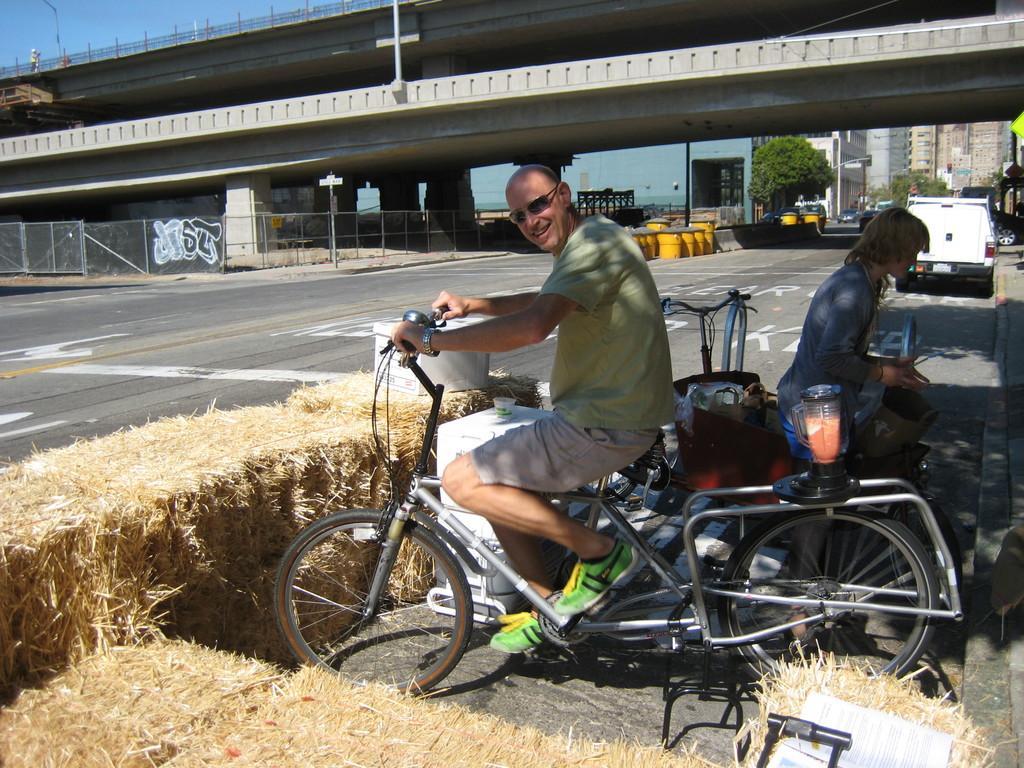How would you summarize this image in a sentence or two? Is the picture there is a cycle and on the cycle a man is sitting,he is smiling behind him there is a woman in front of them there is some grass, dry grass. In the background there is a bridge or a highway,there are some trees,buildings and vehicles also. 